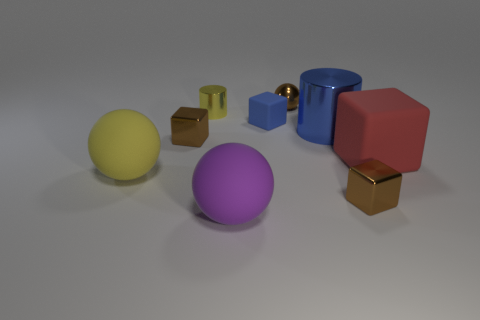What material is the big sphere that is the same color as the tiny cylinder?
Keep it short and to the point. Rubber. How many small brown metal things are the same shape as the large purple rubber thing?
Provide a succinct answer. 1. Are the large blue object and the object behind the tiny yellow metallic cylinder made of the same material?
Provide a succinct answer. Yes. There is a cylinder that is the same size as the purple matte sphere; what is it made of?
Make the answer very short. Metal. Is there another red matte object that has the same size as the red rubber thing?
Your response must be concise. No. There is a blue thing that is the same size as the yellow rubber sphere; what shape is it?
Offer a terse response. Cylinder. How many other things are there of the same color as the small cylinder?
Make the answer very short. 1. What is the shape of the thing that is in front of the large red matte object and to the left of the yellow metal object?
Your answer should be very brief. Sphere. There is a object to the left of the metallic cube on the left side of the large blue thing; are there any purple matte objects that are behind it?
Your answer should be compact. No. What number of other objects are the same material as the large purple ball?
Provide a succinct answer. 3. 